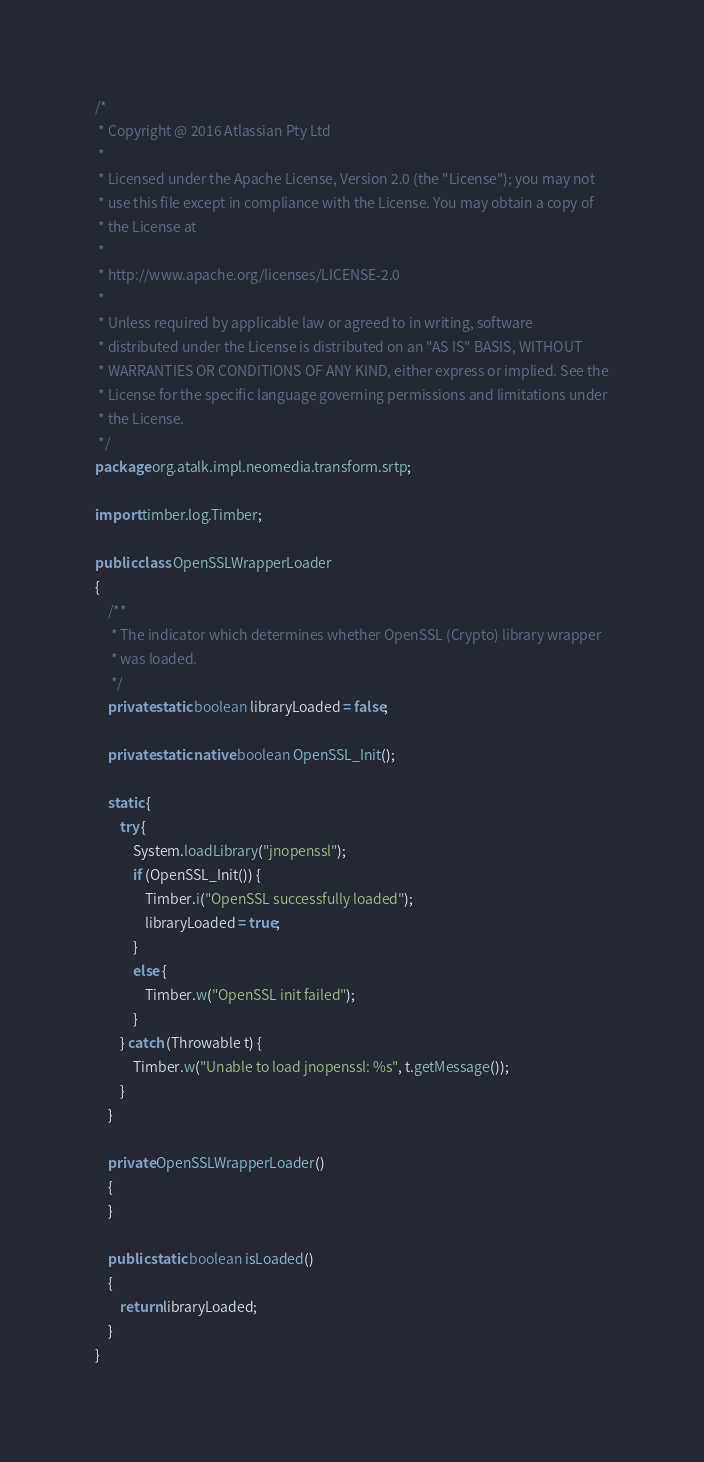Convert code to text. <code><loc_0><loc_0><loc_500><loc_500><_Java_>/*
 * Copyright @ 2016 Atlassian Pty Ltd
 *
 * Licensed under the Apache License, Version 2.0 (the "License"); you may not
 * use this file except in compliance with the License. You may obtain a copy of
 * the License at
 *
 * http://www.apache.org/licenses/LICENSE-2.0
 *
 * Unless required by applicable law or agreed to in writing, software
 * distributed under the License is distributed on an "AS IS" BASIS, WITHOUT
 * WARRANTIES OR CONDITIONS OF ANY KIND, either express or implied. See the
 * License for the specific language governing permissions and limitations under
 * the License.
 */
package org.atalk.impl.neomedia.transform.srtp;

import timber.log.Timber;

public class OpenSSLWrapperLoader
{
    /**
     * The indicator which determines whether OpenSSL (Crypto) library wrapper
     * was loaded.
     */
    private static boolean libraryLoaded = false;

    private static native boolean OpenSSL_Init();

    static {
        try {
            System.loadLibrary("jnopenssl");
            if (OpenSSL_Init()) {
                Timber.i("OpenSSL successfully loaded");
                libraryLoaded = true;
            }
            else {
                Timber.w("OpenSSL init failed");
            }
        } catch (Throwable t) {
            Timber.w("Unable to load jnopenssl: %s", t.getMessage());
        }
    }

    private OpenSSLWrapperLoader()
    {
    }

    public static boolean isLoaded()
    {
        return libraryLoaded;
    }
}
</code> 